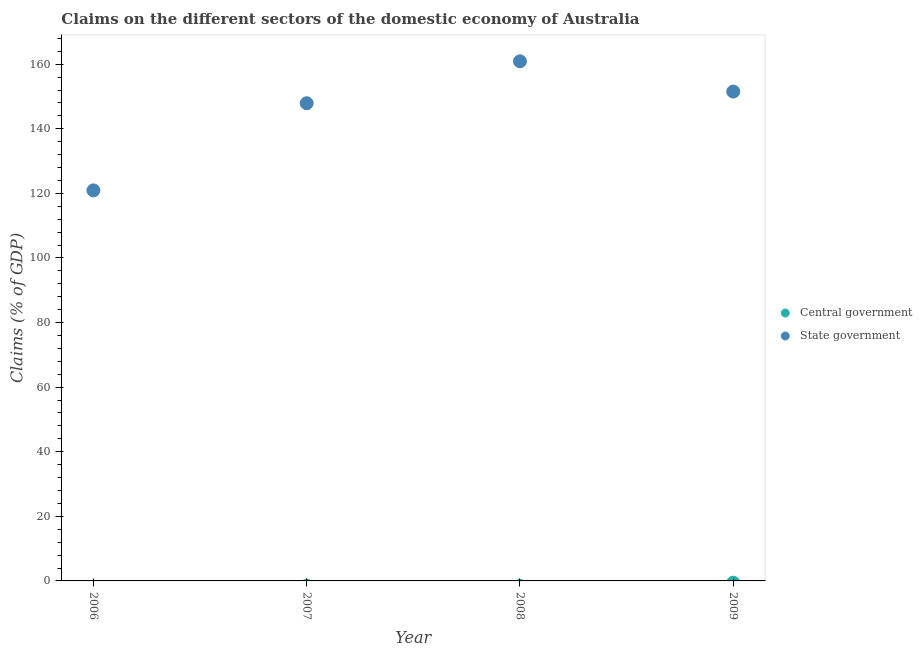How many different coloured dotlines are there?
Ensure brevity in your answer.  1. Is the number of dotlines equal to the number of legend labels?
Offer a very short reply. No. What is the claims on central government in 2009?
Your answer should be very brief. 0. Across all years, what is the maximum claims on state government?
Your answer should be compact. 160.9. Across all years, what is the minimum claims on state government?
Offer a terse response. 120.93. What is the difference between the claims on state government in 2006 and that in 2007?
Make the answer very short. -26.98. What is the difference between the claims on state government in 2007 and the claims on central government in 2006?
Make the answer very short. 147.91. In how many years, is the claims on state government greater than 104 %?
Ensure brevity in your answer.  4. What is the ratio of the claims on state government in 2006 to that in 2009?
Offer a terse response. 0.8. What is the difference between the highest and the lowest claims on state government?
Make the answer very short. 39.97. In how many years, is the claims on central government greater than the average claims on central government taken over all years?
Give a very brief answer. 0. Does the claims on state government monotonically increase over the years?
Your answer should be compact. No. Is the claims on state government strictly less than the claims on central government over the years?
Your response must be concise. No. What is the difference between two consecutive major ticks on the Y-axis?
Keep it short and to the point. 20. Are the values on the major ticks of Y-axis written in scientific E-notation?
Give a very brief answer. No. Does the graph contain any zero values?
Offer a terse response. Yes. Does the graph contain grids?
Provide a short and direct response. No. Where does the legend appear in the graph?
Your answer should be very brief. Center right. How many legend labels are there?
Your answer should be compact. 2. What is the title of the graph?
Make the answer very short. Claims on the different sectors of the domestic economy of Australia. What is the label or title of the X-axis?
Offer a terse response. Year. What is the label or title of the Y-axis?
Provide a succinct answer. Claims (% of GDP). What is the Claims (% of GDP) in State government in 2006?
Offer a very short reply. 120.93. What is the Claims (% of GDP) in State government in 2007?
Your answer should be very brief. 147.91. What is the Claims (% of GDP) in Central government in 2008?
Your answer should be very brief. 0. What is the Claims (% of GDP) in State government in 2008?
Provide a short and direct response. 160.9. What is the Claims (% of GDP) of Central government in 2009?
Provide a succinct answer. 0. What is the Claims (% of GDP) in State government in 2009?
Keep it short and to the point. 151.54. Across all years, what is the maximum Claims (% of GDP) in State government?
Provide a succinct answer. 160.9. Across all years, what is the minimum Claims (% of GDP) in State government?
Your response must be concise. 120.93. What is the total Claims (% of GDP) in Central government in the graph?
Keep it short and to the point. 0. What is the total Claims (% of GDP) of State government in the graph?
Ensure brevity in your answer.  581.29. What is the difference between the Claims (% of GDP) of State government in 2006 and that in 2007?
Offer a terse response. -26.98. What is the difference between the Claims (% of GDP) of State government in 2006 and that in 2008?
Ensure brevity in your answer.  -39.97. What is the difference between the Claims (% of GDP) of State government in 2006 and that in 2009?
Keep it short and to the point. -30.61. What is the difference between the Claims (% of GDP) in State government in 2007 and that in 2008?
Provide a succinct answer. -12.99. What is the difference between the Claims (% of GDP) in State government in 2007 and that in 2009?
Offer a terse response. -3.62. What is the difference between the Claims (% of GDP) in State government in 2008 and that in 2009?
Your answer should be very brief. 9.37. What is the average Claims (% of GDP) in Central government per year?
Offer a very short reply. 0. What is the average Claims (% of GDP) of State government per year?
Ensure brevity in your answer.  145.32. What is the ratio of the Claims (% of GDP) in State government in 2006 to that in 2007?
Your response must be concise. 0.82. What is the ratio of the Claims (% of GDP) in State government in 2006 to that in 2008?
Your answer should be very brief. 0.75. What is the ratio of the Claims (% of GDP) of State government in 2006 to that in 2009?
Provide a succinct answer. 0.8. What is the ratio of the Claims (% of GDP) in State government in 2007 to that in 2008?
Keep it short and to the point. 0.92. What is the ratio of the Claims (% of GDP) of State government in 2007 to that in 2009?
Offer a terse response. 0.98. What is the ratio of the Claims (% of GDP) of State government in 2008 to that in 2009?
Keep it short and to the point. 1.06. What is the difference between the highest and the second highest Claims (% of GDP) in State government?
Your answer should be compact. 9.37. What is the difference between the highest and the lowest Claims (% of GDP) in State government?
Offer a terse response. 39.97. 